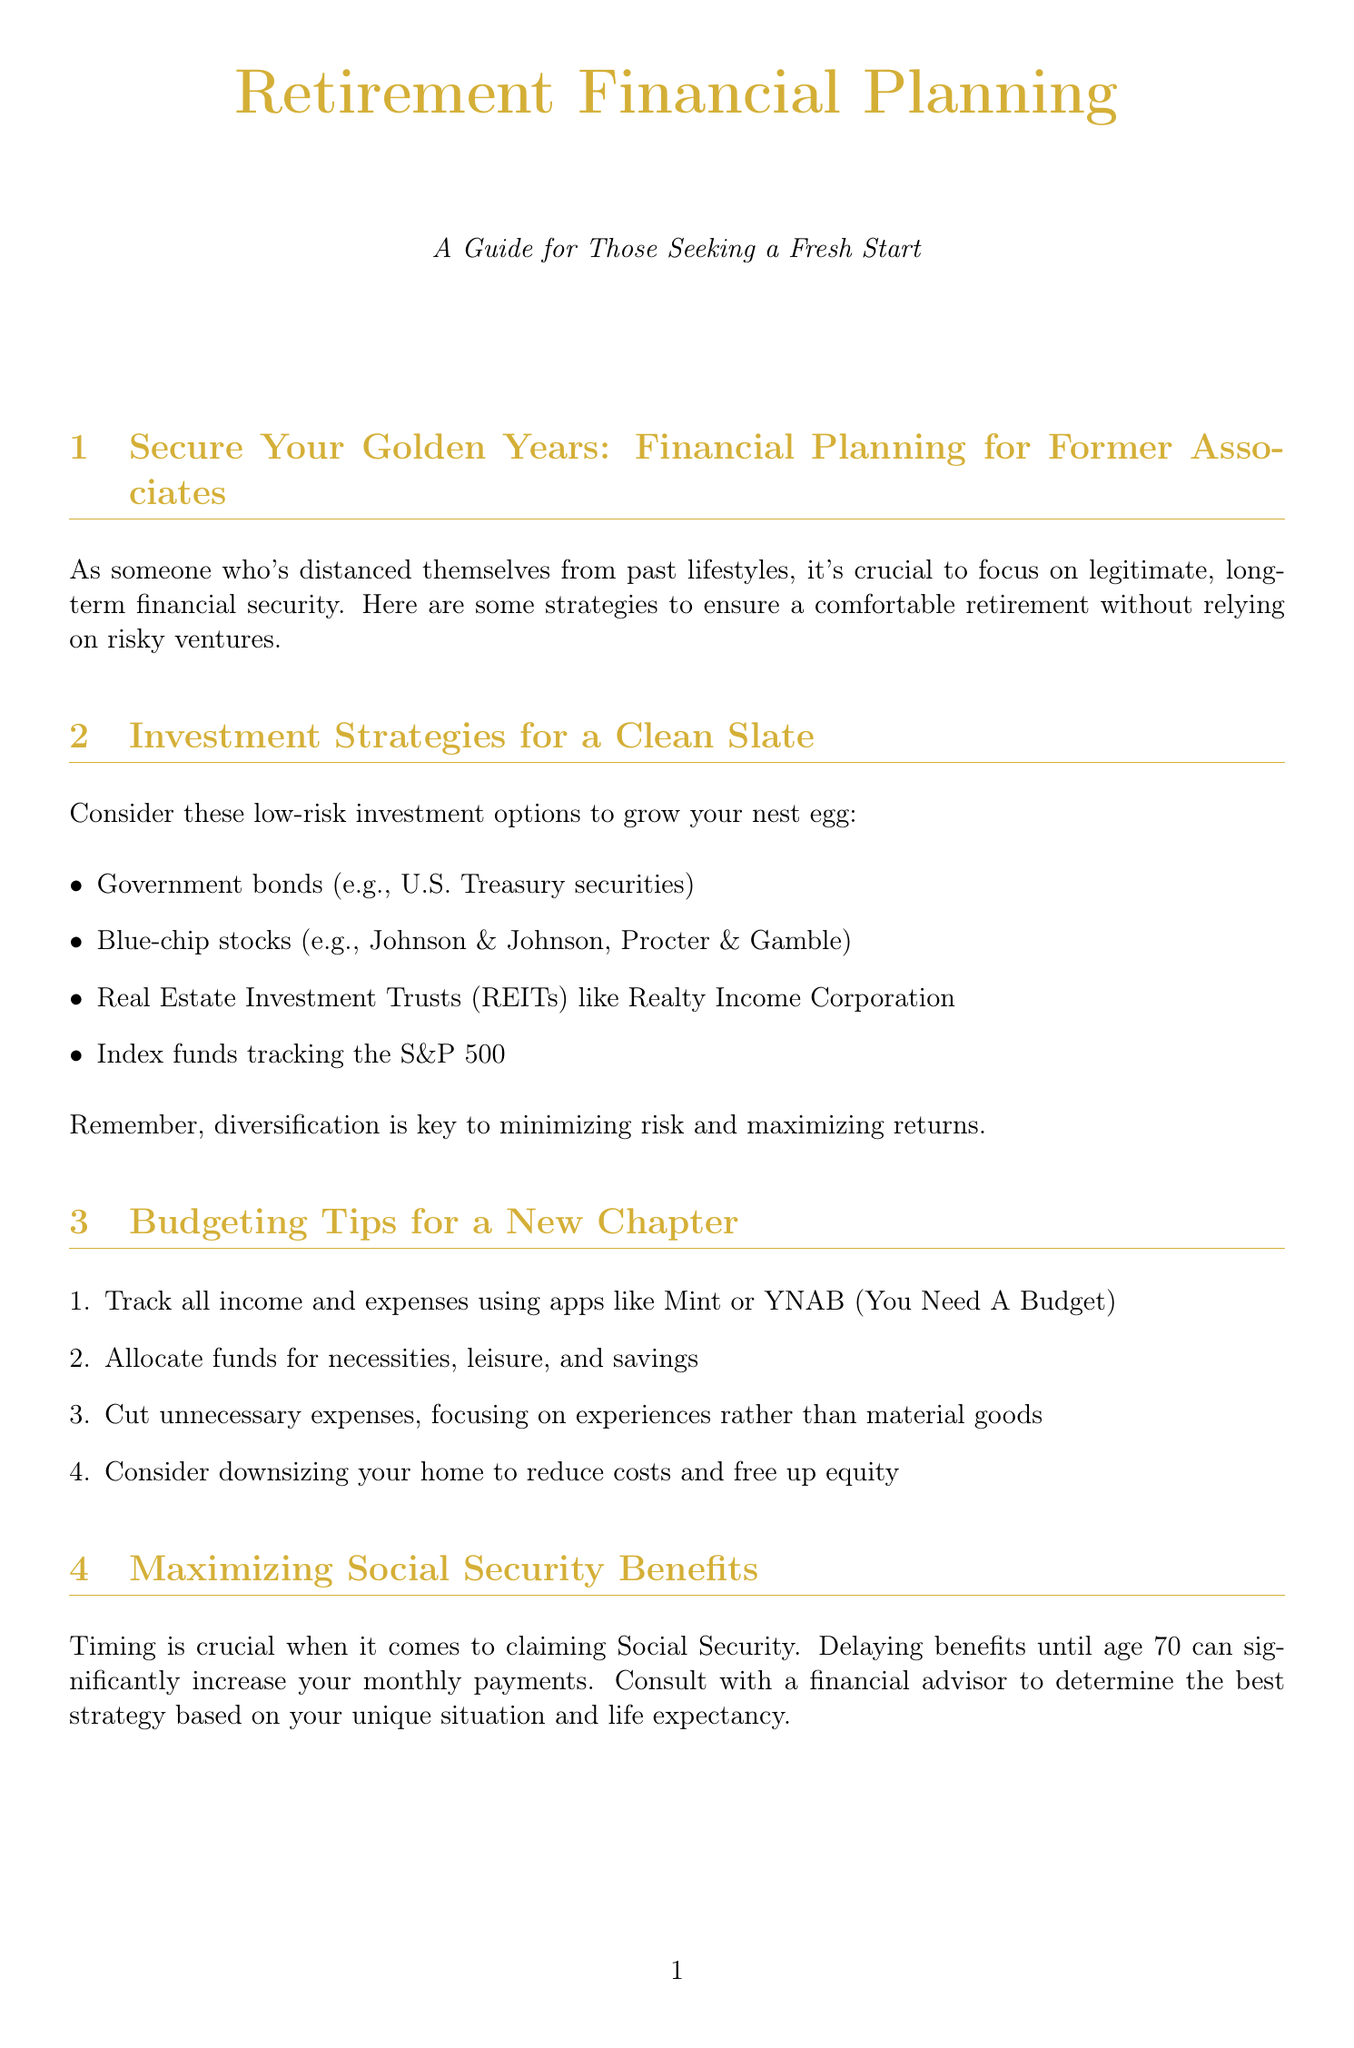What is the title of the newsletter? The title of the newsletter is presented at the beginning of the document under the centered text.
Answer: Retirement Financial Planning What is the recommended age to enroll in Medicare? The document mentions a specific age at which to enroll in Medicare in the healthcare planning section.
Answer: 65 Which investment option is suggested for minimizing risk? The second section lists several options, one of which is specifically focused on minimizing risk.
Answer: Government bonds What is one budgeting app mentioned in the document? The budgeting tips section provides a specific example of an app to track income and expenses.
Answer: Mint What is one way to maximize Social Security benefits? The section on Social Security benefits highlights a specific strategy related to timing.
Answer: Delaying benefits until age 70 Which essential document should be created for estate planning? The estate planning essentials section specifies a crucial document for ensuring asset distribution.
Answer: Will What is one method suggested for embracing a frugal lifestyle? The document outlines several tips for frugal living, and one is derived from the section discussing lifestyle choices.
Answer: Senior discounts How can seniors continue their education in financial literacy? The last section presents various ways seniors can educate themselves on personal finance, one of which is attending events.
Answer: Workshops What type of insurance should seniors consider for supplemental coverage? The healthcare planning section provides suggestions for additional insurance options seniors might want.
Answer: Medigap 